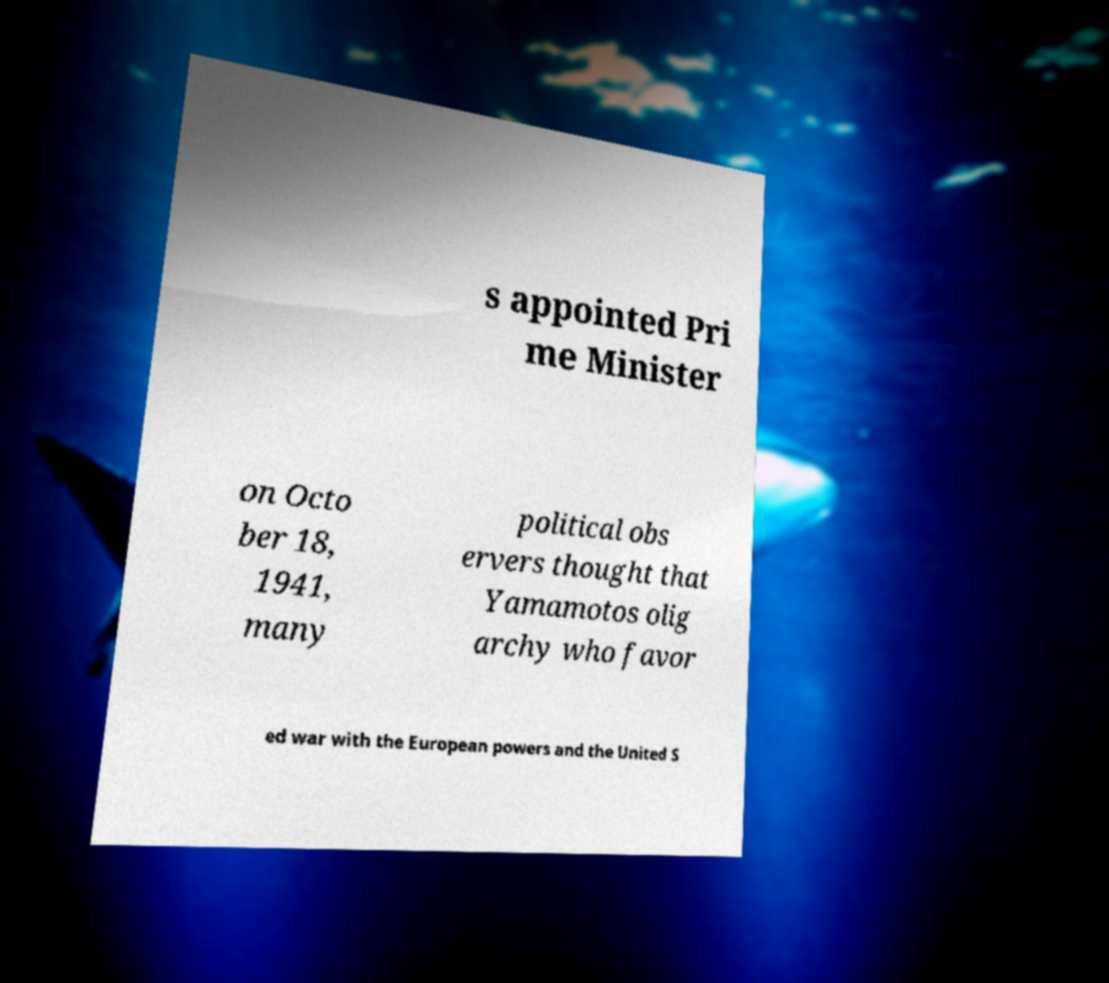Could you assist in decoding the text presented in this image and type it out clearly? s appointed Pri me Minister on Octo ber 18, 1941, many political obs ervers thought that Yamamotos olig archy who favor ed war with the European powers and the United S 